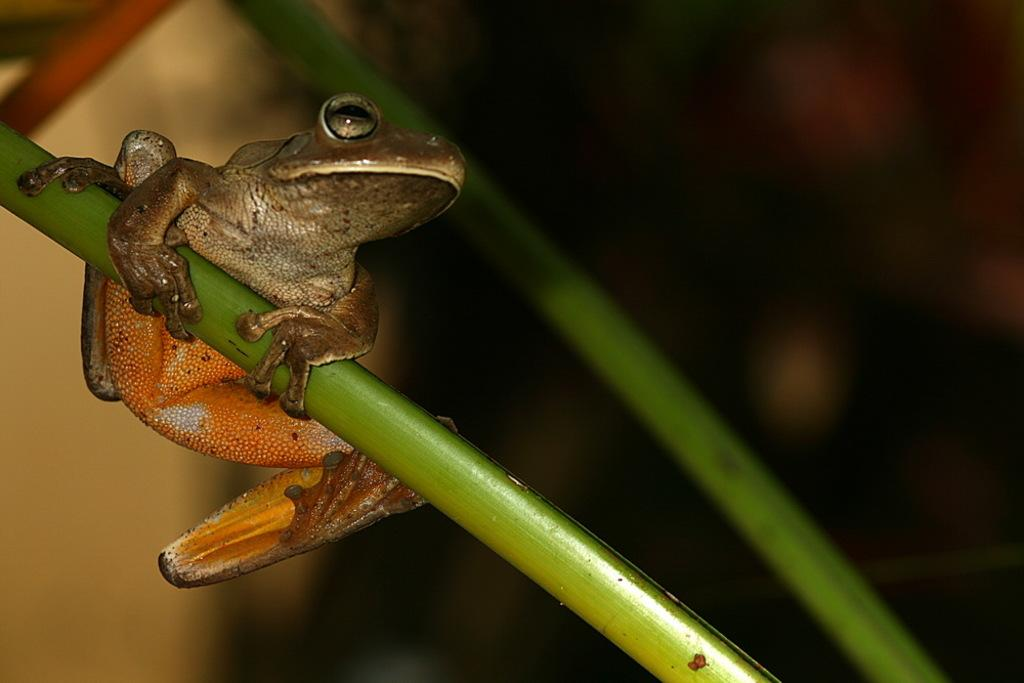What is the main subject of the image? There is a frog on a stem in the image. Are there any other stems visible in the image? Yes, there is another stem beside the frog. Can you describe the background of the image? The background of the image is blurred. What time of day does the frog's hair look its best in the image? There is no mention of hair in the image, as frogs do not have hair. 